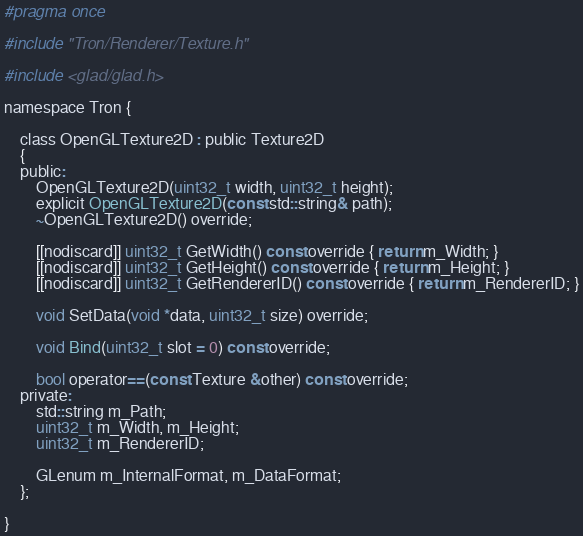<code> <loc_0><loc_0><loc_500><loc_500><_C_>#pragma once

#include "Tron/Renderer/Texture.h"

#include <glad/glad.h>

namespace Tron {

	class OpenGLTexture2D : public Texture2D
	{
	public:
		OpenGLTexture2D(uint32_t width, uint32_t height);
		explicit OpenGLTexture2D(const std::string& path);
		~OpenGLTexture2D() override;

		[[nodiscard]] uint32_t GetWidth() const override { return m_Width; }
		[[nodiscard]] uint32_t GetHeight() const override { return m_Height; }
		[[nodiscard]] uint32_t GetRendererID() const override { return m_RendererID; }

        void SetData(void *data, uint32_t size) override;

		void Bind(uint32_t slot = 0) const override;

        bool operator==(const Texture &other) const override;
    private:
		std::string m_Path;
		uint32_t m_Width, m_Height;
		uint32_t m_RendererID;

		GLenum m_InternalFormat, m_DataFormat;
	};

}

</code> 